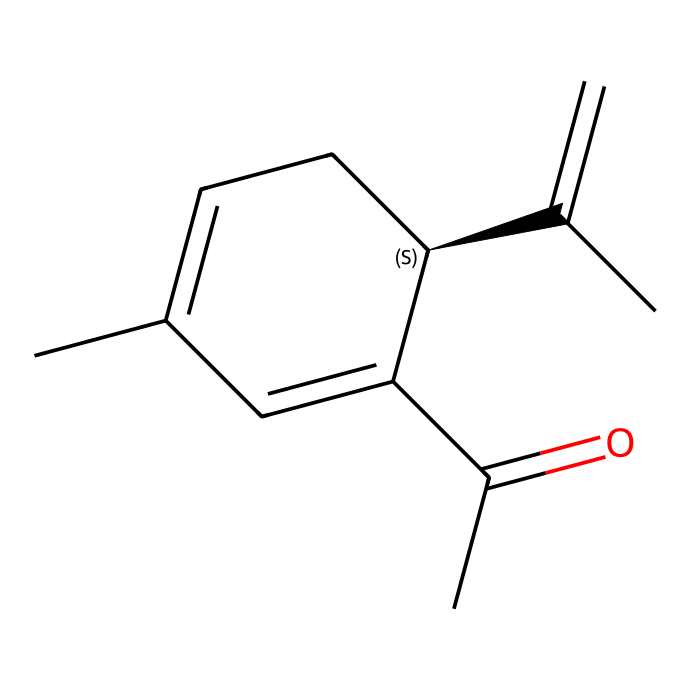What is the molecular formula of carvone? To determine the molecular formula, we count the number of carbon (C), hydrogen (H), and oxygen (O) atoms in the SMILES representation. There are 10 carbon atoms, 14 hydrogen atoms, and 1 oxygen atom in the structure. Therefore, the molecular formula is C10H14O.
Answer: C10H14O How many double bonds are in the structure of carvone? In the given SMILES, we can identify the double bonds by looking for 'C=C' or 'C=O' notations. Upon examining, we find there are 3 double bonds present in carvone's structure.
Answer: 3 What indicates that carvone is a ketone? The presence of the carbonyl group (C=O) within the carbon chain indicates that this compound is a ketone. In the SMILES, we see the 'C(=O)' part which confirms its ketone nature.
Answer: carbonyl group Which functional group characterizes carvone as a ketone? The functional group characteristic of ketones is the carbonyl group (C=O), which is present in the structure of carvone. This group is responsible for carvone's classification as a ketone.
Answer: carbonyl group How many stereocenters are present in the carvone structure? A stereocenter (chiral center) is typically identified by a carbon atom bonded to four different groups. In the SMILES representation, there is one chiral carbon, which indicates the presence of one stereocenter in carvone.
Answer: 1 What is the significance of the stereochemistry in carvone? The stereochemistry determines the spatial arrangement of the atoms, which can lead to different physical properties, biological activities, and aromas in molecules that are isomers. In carvone, the chirality leads to the distinct scent properties of its enantiomers.
Answer: physical properties 